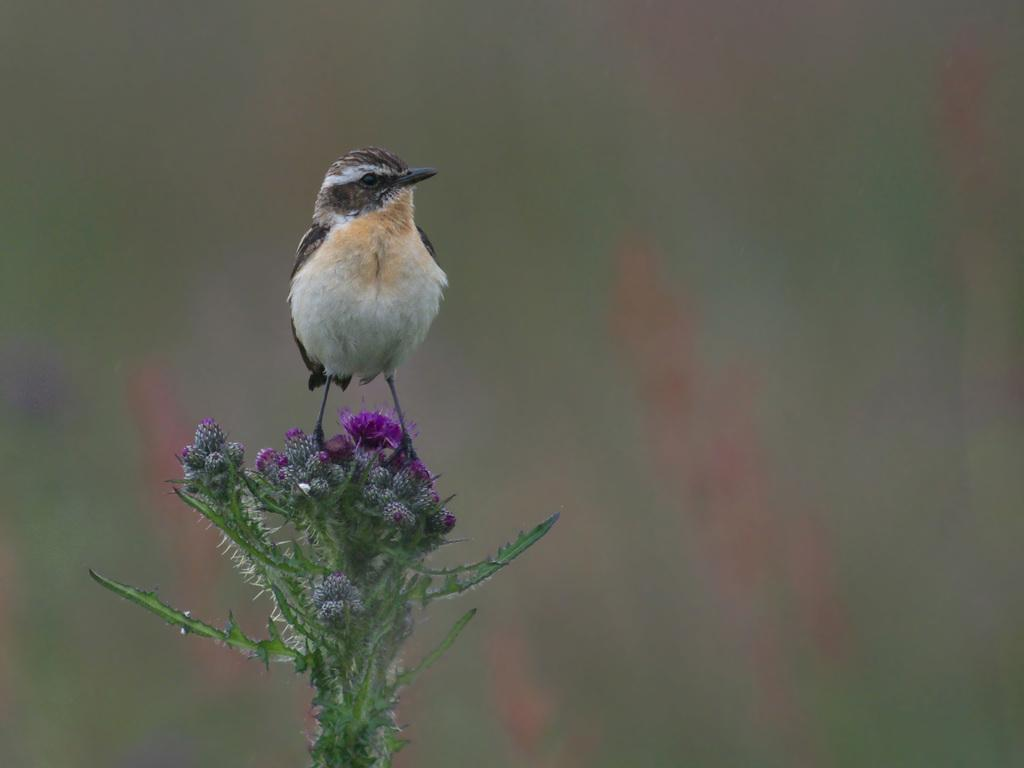What type of animal is in the image? There is a bird in the image. What is the bird standing on? The bird is standing on flowers. Can you describe the background of the image? The background of the image is blurry. How many kittens are playing with the bird in the image? There are no kittens present in the image; it features a bird standing on flowers with a blurry background. 